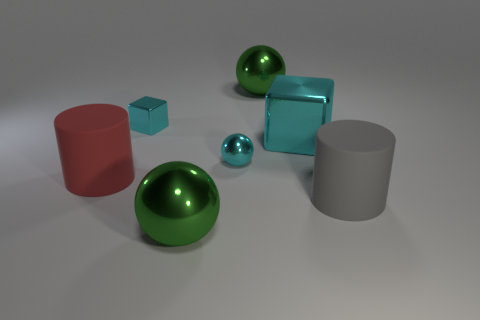What size is the cyan block that is on the left side of the large block behind the red cylinder? The cyan block that is positioned on the left side of the large block behind the red cylinder appears to be smaller when compared with the large block. Since the term 'small' is relative, to clarify, it looks similar in size to the smaller of the two spheres present in the image. 